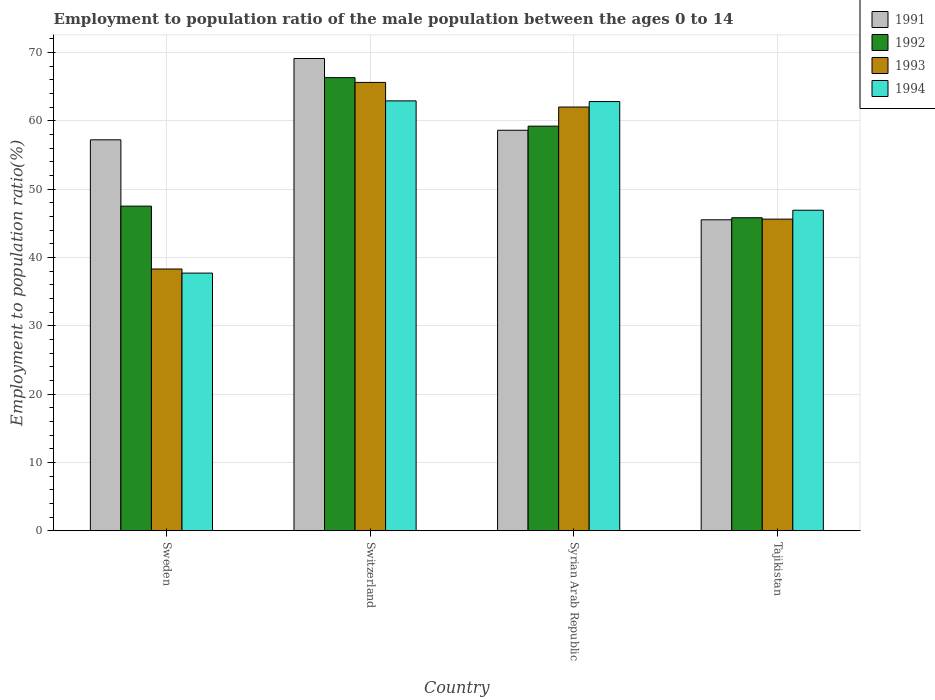How many groups of bars are there?
Your response must be concise. 4. Are the number of bars per tick equal to the number of legend labels?
Give a very brief answer. Yes. How many bars are there on the 3rd tick from the right?
Offer a terse response. 4. What is the label of the 3rd group of bars from the left?
Provide a succinct answer. Syrian Arab Republic. In how many cases, is the number of bars for a given country not equal to the number of legend labels?
Make the answer very short. 0. What is the employment to population ratio in 1993 in Switzerland?
Your answer should be compact. 65.6. Across all countries, what is the maximum employment to population ratio in 1992?
Give a very brief answer. 66.3. Across all countries, what is the minimum employment to population ratio in 1992?
Ensure brevity in your answer.  45.8. In which country was the employment to population ratio in 1993 maximum?
Your answer should be compact. Switzerland. What is the total employment to population ratio in 1993 in the graph?
Give a very brief answer. 211.5. What is the difference between the employment to population ratio in 1994 in Sweden and that in Syrian Arab Republic?
Keep it short and to the point. -25.1. What is the difference between the employment to population ratio in 1992 in Syrian Arab Republic and the employment to population ratio in 1994 in Switzerland?
Offer a very short reply. -3.7. What is the average employment to population ratio in 1994 per country?
Ensure brevity in your answer.  52.58. What is the difference between the employment to population ratio of/in 1991 and employment to population ratio of/in 1992 in Syrian Arab Republic?
Keep it short and to the point. -0.6. What is the ratio of the employment to population ratio in 1994 in Sweden to that in Syrian Arab Republic?
Ensure brevity in your answer.  0.6. Is the employment to population ratio in 1994 in Syrian Arab Republic less than that in Tajikistan?
Offer a very short reply. No. Is the difference between the employment to population ratio in 1991 in Switzerland and Tajikistan greater than the difference between the employment to population ratio in 1992 in Switzerland and Tajikistan?
Offer a terse response. Yes. What is the difference between the highest and the second highest employment to population ratio in 1994?
Offer a very short reply. 15.9. What is the difference between the highest and the lowest employment to population ratio in 1993?
Give a very brief answer. 27.3. Is the sum of the employment to population ratio in 1994 in Sweden and Syrian Arab Republic greater than the maximum employment to population ratio in 1991 across all countries?
Offer a terse response. Yes. Is it the case that in every country, the sum of the employment to population ratio in 1994 and employment to population ratio in 1991 is greater than the sum of employment to population ratio in 1993 and employment to population ratio in 1992?
Your answer should be very brief. No. Are the values on the major ticks of Y-axis written in scientific E-notation?
Provide a succinct answer. No. Does the graph contain any zero values?
Offer a very short reply. No. How many legend labels are there?
Your answer should be very brief. 4. How are the legend labels stacked?
Keep it short and to the point. Vertical. What is the title of the graph?
Your answer should be very brief. Employment to population ratio of the male population between the ages 0 to 14. What is the label or title of the X-axis?
Offer a very short reply. Country. What is the label or title of the Y-axis?
Ensure brevity in your answer.  Employment to population ratio(%). What is the Employment to population ratio(%) in 1991 in Sweden?
Keep it short and to the point. 57.2. What is the Employment to population ratio(%) in 1992 in Sweden?
Make the answer very short. 47.5. What is the Employment to population ratio(%) of 1993 in Sweden?
Offer a terse response. 38.3. What is the Employment to population ratio(%) of 1994 in Sweden?
Provide a short and direct response. 37.7. What is the Employment to population ratio(%) of 1991 in Switzerland?
Give a very brief answer. 69.1. What is the Employment to population ratio(%) of 1992 in Switzerland?
Your response must be concise. 66.3. What is the Employment to population ratio(%) of 1993 in Switzerland?
Make the answer very short. 65.6. What is the Employment to population ratio(%) of 1994 in Switzerland?
Ensure brevity in your answer.  62.9. What is the Employment to population ratio(%) of 1991 in Syrian Arab Republic?
Your answer should be compact. 58.6. What is the Employment to population ratio(%) in 1992 in Syrian Arab Republic?
Your answer should be very brief. 59.2. What is the Employment to population ratio(%) in 1993 in Syrian Arab Republic?
Ensure brevity in your answer.  62. What is the Employment to population ratio(%) of 1994 in Syrian Arab Republic?
Your answer should be very brief. 62.8. What is the Employment to population ratio(%) in 1991 in Tajikistan?
Provide a short and direct response. 45.5. What is the Employment to population ratio(%) of 1992 in Tajikistan?
Provide a short and direct response. 45.8. What is the Employment to population ratio(%) in 1993 in Tajikistan?
Your response must be concise. 45.6. What is the Employment to population ratio(%) in 1994 in Tajikistan?
Keep it short and to the point. 46.9. Across all countries, what is the maximum Employment to population ratio(%) of 1991?
Keep it short and to the point. 69.1. Across all countries, what is the maximum Employment to population ratio(%) of 1992?
Provide a short and direct response. 66.3. Across all countries, what is the maximum Employment to population ratio(%) of 1993?
Ensure brevity in your answer.  65.6. Across all countries, what is the maximum Employment to population ratio(%) in 1994?
Your answer should be very brief. 62.9. Across all countries, what is the minimum Employment to population ratio(%) of 1991?
Ensure brevity in your answer.  45.5. Across all countries, what is the minimum Employment to population ratio(%) of 1992?
Offer a very short reply. 45.8. Across all countries, what is the minimum Employment to population ratio(%) in 1993?
Keep it short and to the point. 38.3. Across all countries, what is the minimum Employment to population ratio(%) of 1994?
Keep it short and to the point. 37.7. What is the total Employment to population ratio(%) of 1991 in the graph?
Make the answer very short. 230.4. What is the total Employment to population ratio(%) in 1992 in the graph?
Give a very brief answer. 218.8. What is the total Employment to population ratio(%) of 1993 in the graph?
Provide a succinct answer. 211.5. What is the total Employment to population ratio(%) of 1994 in the graph?
Your response must be concise. 210.3. What is the difference between the Employment to population ratio(%) in 1991 in Sweden and that in Switzerland?
Provide a succinct answer. -11.9. What is the difference between the Employment to population ratio(%) in 1992 in Sweden and that in Switzerland?
Give a very brief answer. -18.8. What is the difference between the Employment to population ratio(%) of 1993 in Sweden and that in Switzerland?
Offer a terse response. -27.3. What is the difference between the Employment to population ratio(%) in 1994 in Sweden and that in Switzerland?
Offer a terse response. -25.2. What is the difference between the Employment to population ratio(%) of 1991 in Sweden and that in Syrian Arab Republic?
Your answer should be very brief. -1.4. What is the difference between the Employment to population ratio(%) in 1992 in Sweden and that in Syrian Arab Republic?
Keep it short and to the point. -11.7. What is the difference between the Employment to population ratio(%) in 1993 in Sweden and that in Syrian Arab Republic?
Your answer should be compact. -23.7. What is the difference between the Employment to population ratio(%) of 1994 in Sweden and that in Syrian Arab Republic?
Provide a succinct answer. -25.1. What is the difference between the Employment to population ratio(%) of 1991 in Sweden and that in Tajikistan?
Make the answer very short. 11.7. What is the difference between the Employment to population ratio(%) in 1992 in Sweden and that in Tajikistan?
Your response must be concise. 1.7. What is the difference between the Employment to population ratio(%) in 1991 in Switzerland and that in Syrian Arab Republic?
Make the answer very short. 10.5. What is the difference between the Employment to population ratio(%) of 1992 in Switzerland and that in Syrian Arab Republic?
Your answer should be compact. 7.1. What is the difference between the Employment to population ratio(%) of 1993 in Switzerland and that in Syrian Arab Republic?
Your answer should be compact. 3.6. What is the difference between the Employment to population ratio(%) in 1994 in Switzerland and that in Syrian Arab Republic?
Offer a very short reply. 0.1. What is the difference between the Employment to population ratio(%) of 1991 in Switzerland and that in Tajikistan?
Ensure brevity in your answer.  23.6. What is the difference between the Employment to population ratio(%) in 1991 in Syrian Arab Republic and that in Tajikistan?
Offer a very short reply. 13.1. What is the difference between the Employment to population ratio(%) of 1993 in Syrian Arab Republic and that in Tajikistan?
Provide a succinct answer. 16.4. What is the difference between the Employment to population ratio(%) of 1991 in Sweden and the Employment to population ratio(%) of 1992 in Switzerland?
Make the answer very short. -9.1. What is the difference between the Employment to population ratio(%) of 1992 in Sweden and the Employment to population ratio(%) of 1993 in Switzerland?
Give a very brief answer. -18.1. What is the difference between the Employment to population ratio(%) in 1992 in Sweden and the Employment to population ratio(%) in 1994 in Switzerland?
Offer a very short reply. -15.4. What is the difference between the Employment to population ratio(%) in 1993 in Sweden and the Employment to population ratio(%) in 1994 in Switzerland?
Offer a very short reply. -24.6. What is the difference between the Employment to population ratio(%) of 1991 in Sweden and the Employment to population ratio(%) of 1993 in Syrian Arab Republic?
Your answer should be very brief. -4.8. What is the difference between the Employment to population ratio(%) of 1992 in Sweden and the Employment to population ratio(%) of 1993 in Syrian Arab Republic?
Your answer should be compact. -14.5. What is the difference between the Employment to population ratio(%) of 1992 in Sweden and the Employment to population ratio(%) of 1994 in Syrian Arab Republic?
Your answer should be very brief. -15.3. What is the difference between the Employment to population ratio(%) in 1993 in Sweden and the Employment to population ratio(%) in 1994 in Syrian Arab Republic?
Offer a very short reply. -24.5. What is the difference between the Employment to population ratio(%) of 1991 in Sweden and the Employment to population ratio(%) of 1992 in Tajikistan?
Your response must be concise. 11.4. What is the difference between the Employment to population ratio(%) of 1991 in Sweden and the Employment to population ratio(%) of 1993 in Tajikistan?
Keep it short and to the point. 11.6. What is the difference between the Employment to population ratio(%) in 1992 in Sweden and the Employment to population ratio(%) in 1993 in Tajikistan?
Offer a very short reply. 1.9. What is the difference between the Employment to population ratio(%) of 1992 in Sweden and the Employment to population ratio(%) of 1994 in Tajikistan?
Your response must be concise. 0.6. What is the difference between the Employment to population ratio(%) of 1991 in Switzerland and the Employment to population ratio(%) of 1993 in Syrian Arab Republic?
Your response must be concise. 7.1. What is the difference between the Employment to population ratio(%) of 1992 in Switzerland and the Employment to population ratio(%) of 1994 in Syrian Arab Republic?
Offer a terse response. 3.5. What is the difference between the Employment to population ratio(%) of 1991 in Switzerland and the Employment to population ratio(%) of 1992 in Tajikistan?
Your answer should be very brief. 23.3. What is the difference between the Employment to population ratio(%) of 1991 in Switzerland and the Employment to population ratio(%) of 1993 in Tajikistan?
Provide a short and direct response. 23.5. What is the difference between the Employment to population ratio(%) in 1992 in Switzerland and the Employment to population ratio(%) in 1993 in Tajikistan?
Your answer should be very brief. 20.7. What is the difference between the Employment to population ratio(%) of 1991 in Syrian Arab Republic and the Employment to population ratio(%) of 1993 in Tajikistan?
Make the answer very short. 13. What is the difference between the Employment to population ratio(%) in 1992 in Syrian Arab Republic and the Employment to population ratio(%) in 1993 in Tajikistan?
Ensure brevity in your answer.  13.6. What is the average Employment to population ratio(%) in 1991 per country?
Your answer should be compact. 57.6. What is the average Employment to population ratio(%) in 1992 per country?
Your response must be concise. 54.7. What is the average Employment to population ratio(%) of 1993 per country?
Make the answer very short. 52.88. What is the average Employment to population ratio(%) of 1994 per country?
Ensure brevity in your answer.  52.58. What is the difference between the Employment to population ratio(%) of 1991 and Employment to population ratio(%) of 1994 in Sweden?
Your answer should be very brief. 19.5. What is the difference between the Employment to population ratio(%) of 1992 and Employment to population ratio(%) of 1993 in Sweden?
Keep it short and to the point. 9.2. What is the difference between the Employment to population ratio(%) in 1991 and Employment to population ratio(%) in 1992 in Switzerland?
Your answer should be very brief. 2.8. What is the difference between the Employment to population ratio(%) in 1991 and Employment to population ratio(%) in 1993 in Switzerland?
Keep it short and to the point. 3.5. What is the difference between the Employment to population ratio(%) in 1992 and Employment to population ratio(%) in 1993 in Switzerland?
Offer a very short reply. 0.7. What is the difference between the Employment to population ratio(%) in 1991 and Employment to population ratio(%) in 1992 in Syrian Arab Republic?
Offer a very short reply. -0.6. What is the difference between the Employment to population ratio(%) of 1991 and Employment to population ratio(%) of 1994 in Syrian Arab Republic?
Your answer should be compact. -4.2. What is the difference between the Employment to population ratio(%) in 1992 and Employment to population ratio(%) in 1993 in Syrian Arab Republic?
Ensure brevity in your answer.  -2.8. What is the difference between the Employment to population ratio(%) in 1992 and Employment to population ratio(%) in 1994 in Syrian Arab Republic?
Offer a terse response. -3.6. What is the difference between the Employment to population ratio(%) of 1991 and Employment to population ratio(%) of 1993 in Tajikistan?
Give a very brief answer. -0.1. What is the difference between the Employment to population ratio(%) in 1992 and Employment to population ratio(%) in 1993 in Tajikistan?
Your answer should be very brief. 0.2. What is the ratio of the Employment to population ratio(%) in 1991 in Sweden to that in Switzerland?
Your response must be concise. 0.83. What is the ratio of the Employment to population ratio(%) in 1992 in Sweden to that in Switzerland?
Your response must be concise. 0.72. What is the ratio of the Employment to population ratio(%) in 1993 in Sweden to that in Switzerland?
Offer a terse response. 0.58. What is the ratio of the Employment to population ratio(%) in 1994 in Sweden to that in Switzerland?
Ensure brevity in your answer.  0.6. What is the ratio of the Employment to population ratio(%) in 1991 in Sweden to that in Syrian Arab Republic?
Offer a terse response. 0.98. What is the ratio of the Employment to population ratio(%) of 1992 in Sweden to that in Syrian Arab Republic?
Your answer should be compact. 0.8. What is the ratio of the Employment to population ratio(%) in 1993 in Sweden to that in Syrian Arab Republic?
Ensure brevity in your answer.  0.62. What is the ratio of the Employment to population ratio(%) in 1994 in Sweden to that in Syrian Arab Republic?
Your answer should be compact. 0.6. What is the ratio of the Employment to population ratio(%) of 1991 in Sweden to that in Tajikistan?
Make the answer very short. 1.26. What is the ratio of the Employment to population ratio(%) in 1992 in Sweden to that in Tajikistan?
Provide a succinct answer. 1.04. What is the ratio of the Employment to population ratio(%) in 1993 in Sweden to that in Tajikistan?
Make the answer very short. 0.84. What is the ratio of the Employment to population ratio(%) in 1994 in Sweden to that in Tajikistan?
Give a very brief answer. 0.8. What is the ratio of the Employment to population ratio(%) in 1991 in Switzerland to that in Syrian Arab Republic?
Your response must be concise. 1.18. What is the ratio of the Employment to population ratio(%) in 1992 in Switzerland to that in Syrian Arab Republic?
Your answer should be compact. 1.12. What is the ratio of the Employment to population ratio(%) in 1993 in Switzerland to that in Syrian Arab Republic?
Ensure brevity in your answer.  1.06. What is the ratio of the Employment to population ratio(%) of 1994 in Switzerland to that in Syrian Arab Republic?
Your answer should be compact. 1. What is the ratio of the Employment to population ratio(%) in 1991 in Switzerland to that in Tajikistan?
Give a very brief answer. 1.52. What is the ratio of the Employment to population ratio(%) of 1992 in Switzerland to that in Tajikistan?
Make the answer very short. 1.45. What is the ratio of the Employment to population ratio(%) of 1993 in Switzerland to that in Tajikistan?
Ensure brevity in your answer.  1.44. What is the ratio of the Employment to population ratio(%) of 1994 in Switzerland to that in Tajikistan?
Offer a very short reply. 1.34. What is the ratio of the Employment to population ratio(%) in 1991 in Syrian Arab Republic to that in Tajikistan?
Your answer should be very brief. 1.29. What is the ratio of the Employment to population ratio(%) in 1992 in Syrian Arab Republic to that in Tajikistan?
Keep it short and to the point. 1.29. What is the ratio of the Employment to population ratio(%) of 1993 in Syrian Arab Republic to that in Tajikistan?
Your answer should be compact. 1.36. What is the ratio of the Employment to population ratio(%) of 1994 in Syrian Arab Republic to that in Tajikistan?
Keep it short and to the point. 1.34. What is the difference between the highest and the second highest Employment to population ratio(%) of 1991?
Your answer should be compact. 10.5. What is the difference between the highest and the second highest Employment to population ratio(%) in 1992?
Offer a very short reply. 7.1. What is the difference between the highest and the second highest Employment to population ratio(%) of 1994?
Provide a short and direct response. 0.1. What is the difference between the highest and the lowest Employment to population ratio(%) of 1991?
Your answer should be compact. 23.6. What is the difference between the highest and the lowest Employment to population ratio(%) of 1993?
Ensure brevity in your answer.  27.3. What is the difference between the highest and the lowest Employment to population ratio(%) in 1994?
Your answer should be very brief. 25.2. 